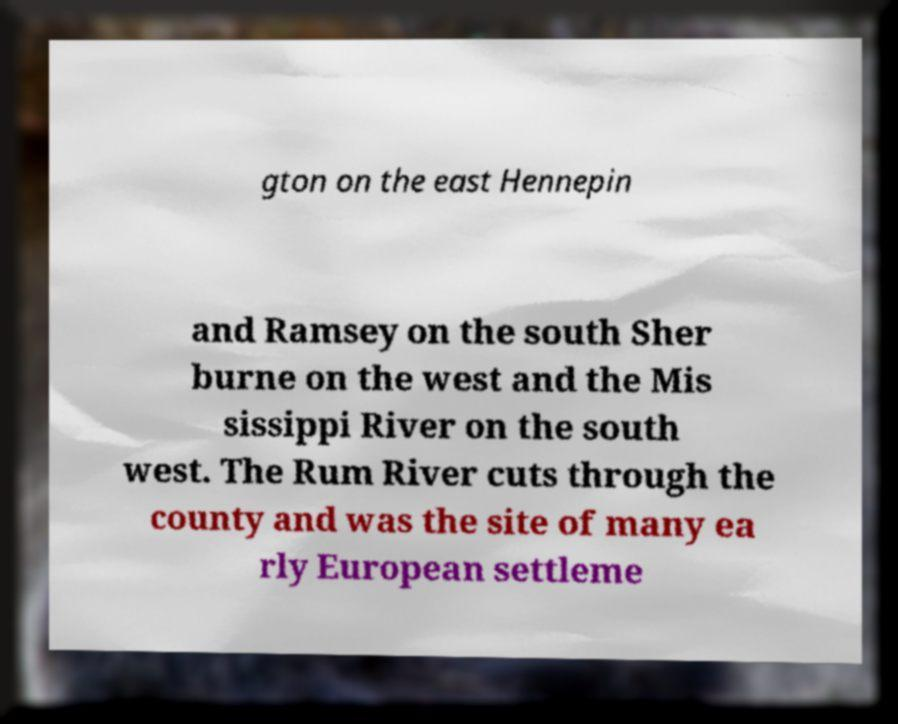For documentation purposes, I need the text within this image transcribed. Could you provide that? gton on the east Hennepin and Ramsey on the south Sher burne on the west and the Mis sissippi River on the south west. The Rum River cuts through the county and was the site of many ea rly European settleme 